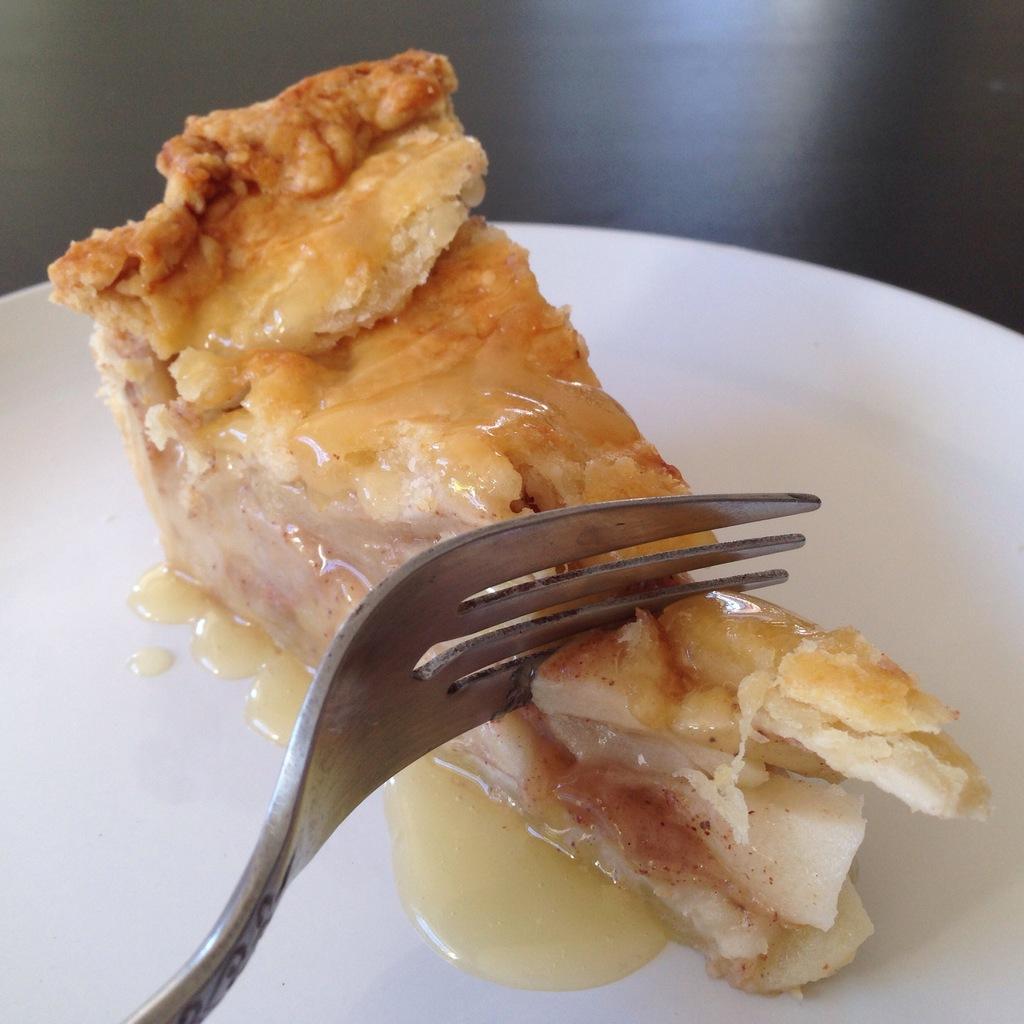Could you give a brief overview of what you see in this image? Here I can see a plate which consists of some food item and fork. This plate is placed on a table. 